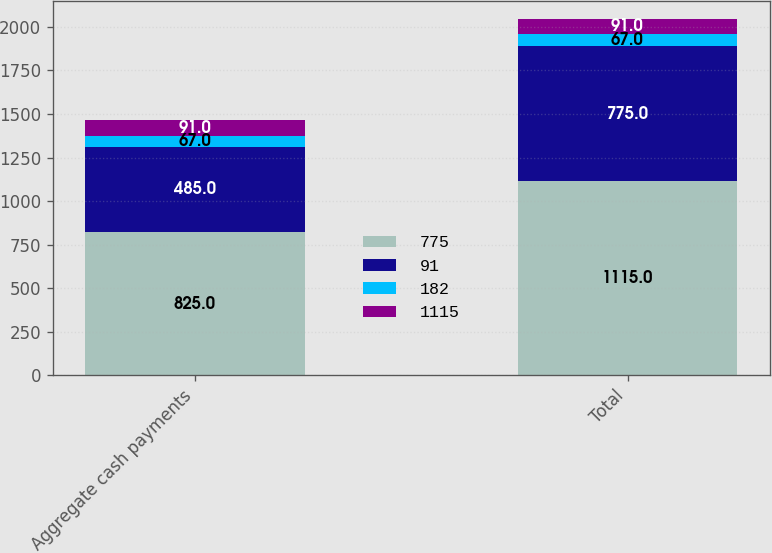Convert chart. <chart><loc_0><loc_0><loc_500><loc_500><stacked_bar_chart><ecel><fcel>Aggregate cash payments<fcel>Total<nl><fcel>775<fcel>825<fcel>1115<nl><fcel>91<fcel>485<fcel>775<nl><fcel>182<fcel>67<fcel>67<nl><fcel>1115<fcel>91<fcel>91<nl></chart> 